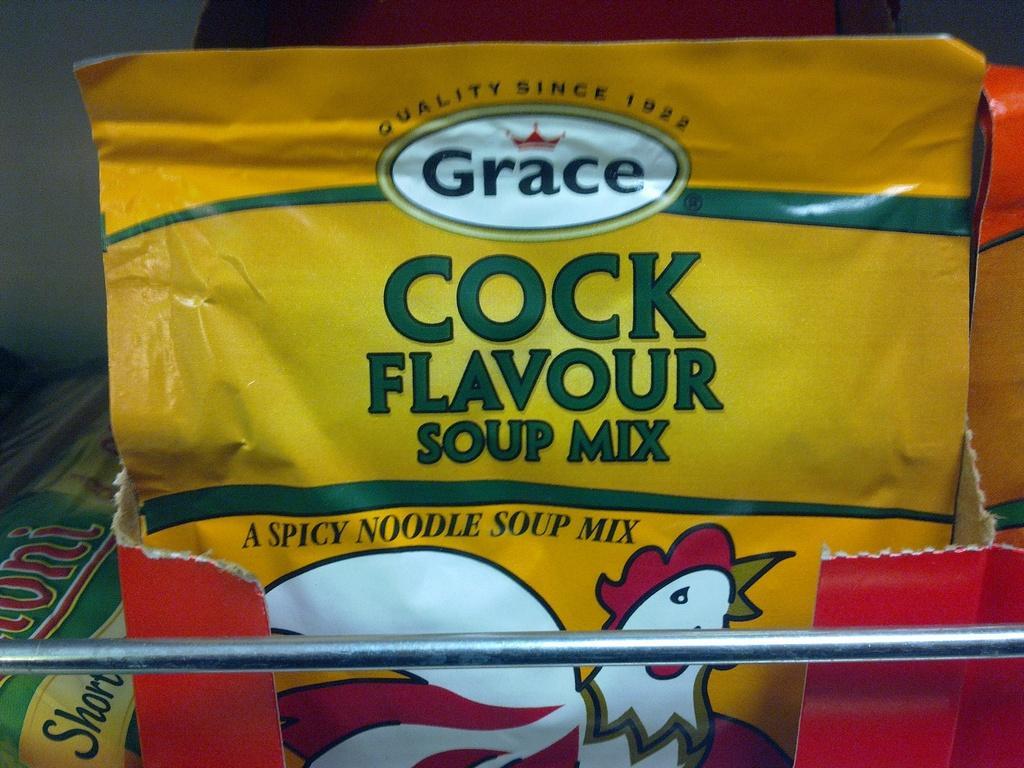Please provide a concise description of this image. In this image there is a soup packet which is in the box. At the bottom there is an iron rod. 